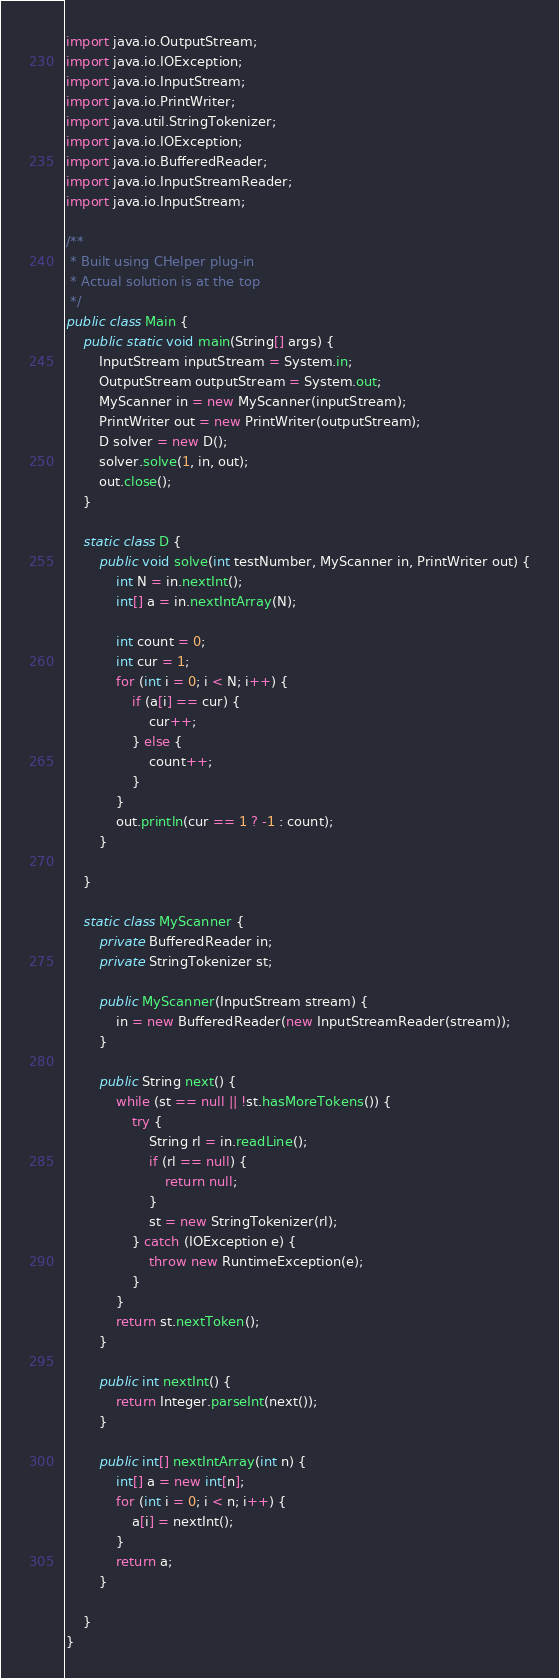<code> <loc_0><loc_0><loc_500><loc_500><_Java_>import java.io.OutputStream;
import java.io.IOException;
import java.io.InputStream;
import java.io.PrintWriter;
import java.util.StringTokenizer;
import java.io.IOException;
import java.io.BufferedReader;
import java.io.InputStreamReader;
import java.io.InputStream;

/**
 * Built using CHelper plug-in
 * Actual solution is at the top
 */
public class Main {
    public static void main(String[] args) {
        InputStream inputStream = System.in;
        OutputStream outputStream = System.out;
        MyScanner in = new MyScanner(inputStream);
        PrintWriter out = new PrintWriter(outputStream);
        D solver = new D();
        solver.solve(1, in, out);
        out.close();
    }

    static class D {
        public void solve(int testNumber, MyScanner in, PrintWriter out) {
            int N = in.nextInt();
            int[] a = in.nextIntArray(N);

            int count = 0;
            int cur = 1;
            for (int i = 0; i < N; i++) {
                if (a[i] == cur) {
                    cur++;
                } else {
                    count++;
                }
            }
            out.println(cur == 1 ? -1 : count);
        }

    }

    static class MyScanner {
        private BufferedReader in;
        private StringTokenizer st;

        public MyScanner(InputStream stream) {
            in = new BufferedReader(new InputStreamReader(stream));
        }

        public String next() {
            while (st == null || !st.hasMoreTokens()) {
                try {
                    String rl = in.readLine();
                    if (rl == null) {
                        return null;
                    }
                    st = new StringTokenizer(rl);
                } catch (IOException e) {
                    throw new RuntimeException(e);
                }
            }
            return st.nextToken();
        }

        public int nextInt() {
            return Integer.parseInt(next());
        }

        public int[] nextIntArray(int n) {
            int[] a = new int[n];
            for (int i = 0; i < n; i++) {
                a[i] = nextInt();
            }
            return a;
        }

    }
}

</code> 